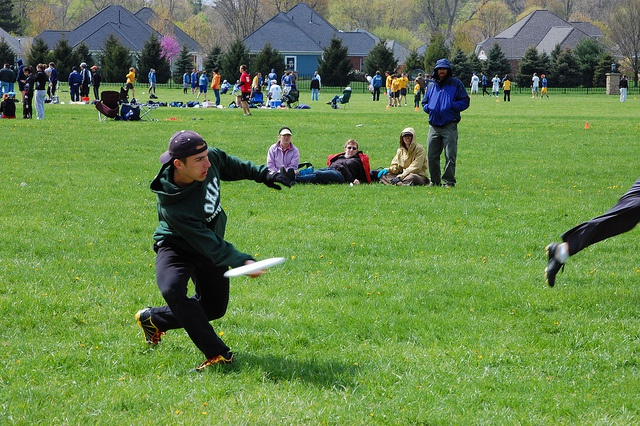Describe the objects in this image and their specific colors. I can see people in black, lightgreen, and green tones, people in black, navy, olive, and lightgreen tones, people in black, gray, darkgray, and green tones, people in black, gray, navy, and blue tones, and people in black, olive, and gray tones in this image. 